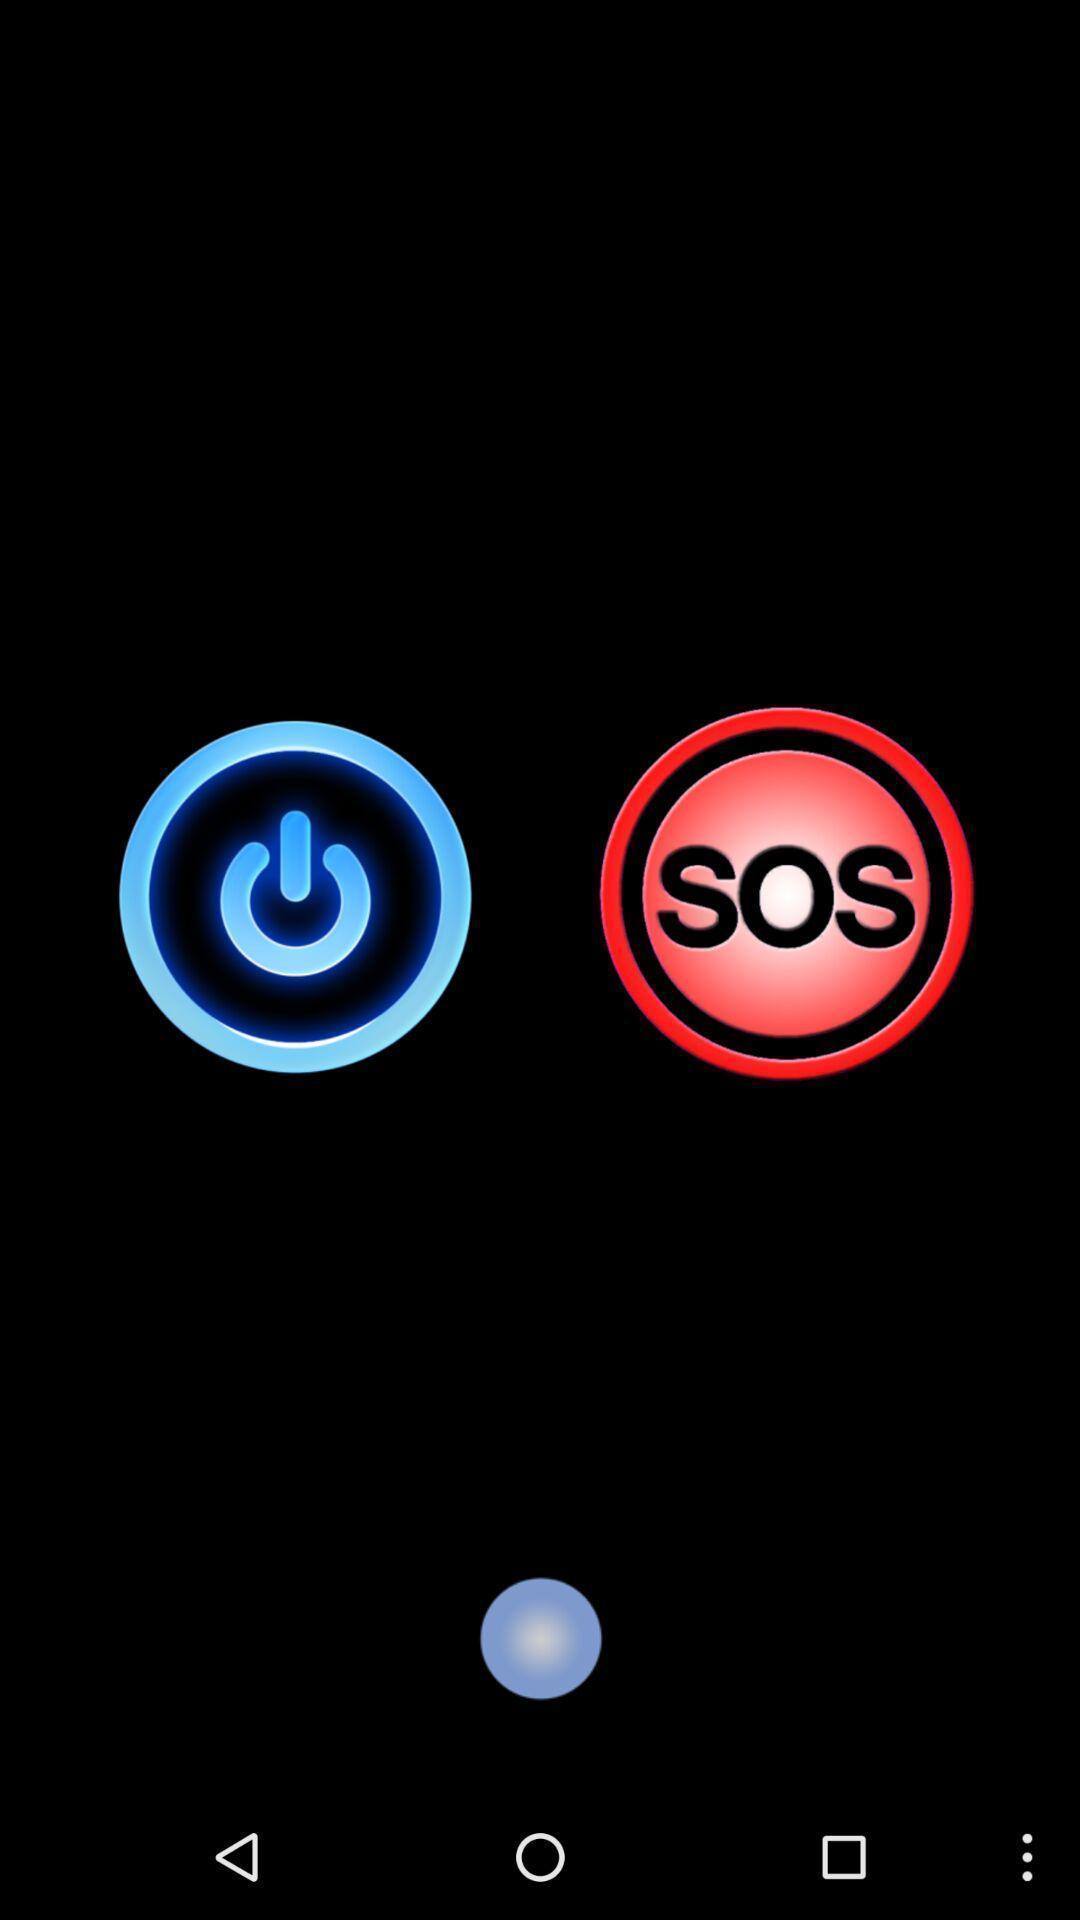Tell me what you see in this picture. Screen displaying the power button and emergency call options. 